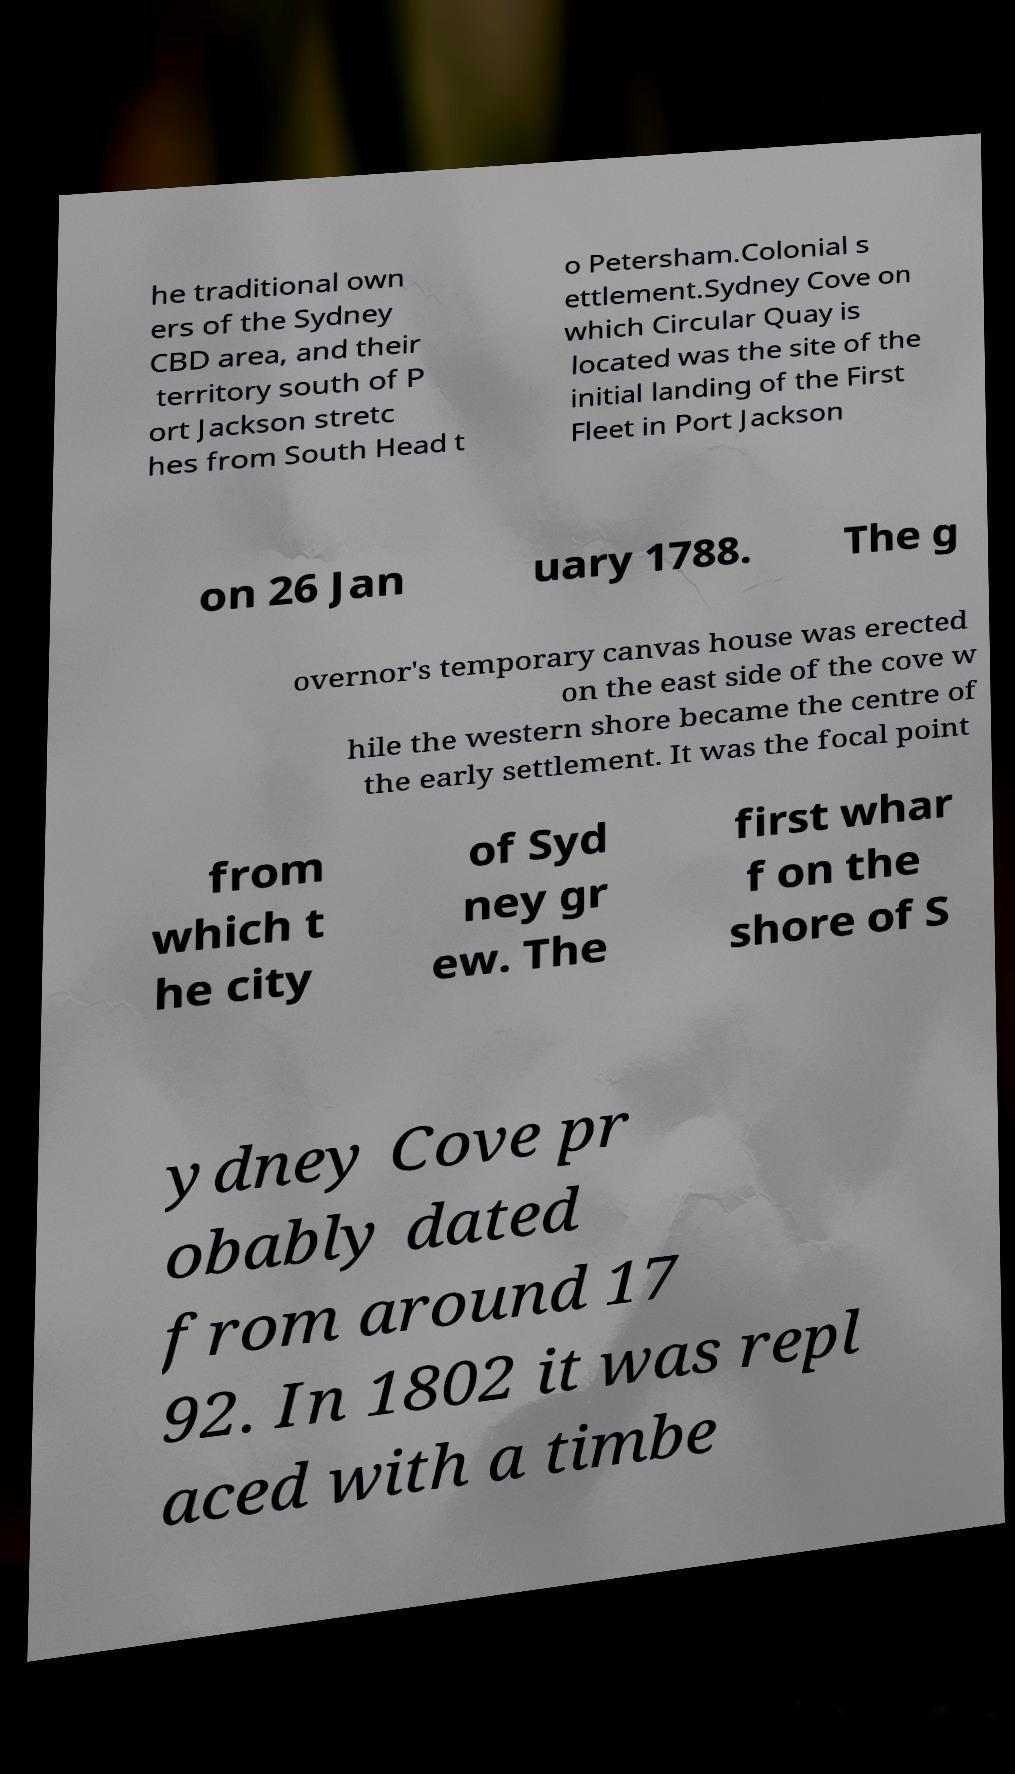There's text embedded in this image that I need extracted. Can you transcribe it verbatim? he traditional own ers of the Sydney CBD area, and their territory south of P ort Jackson stretc hes from South Head t o Petersham.Colonial s ettlement.Sydney Cove on which Circular Quay is located was the site of the initial landing of the First Fleet in Port Jackson on 26 Jan uary 1788. The g overnor's temporary canvas house was erected on the east side of the cove w hile the western shore became the centre of the early settlement. It was the focal point from which t he city of Syd ney gr ew. The first whar f on the shore of S ydney Cove pr obably dated from around 17 92. In 1802 it was repl aced with a timbe 